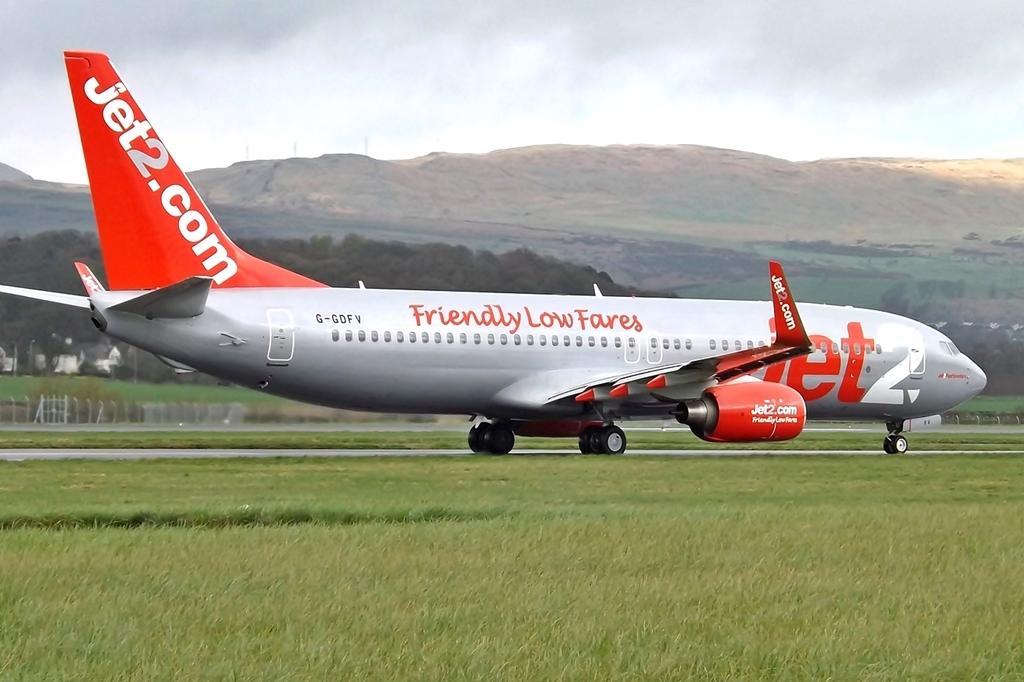How would you summarize this image in a sentence or two? In this picture we can see an airplane on the ground, beside this ground we can see grass, fence, houses, trees and in the background we can see mountains, sky. 